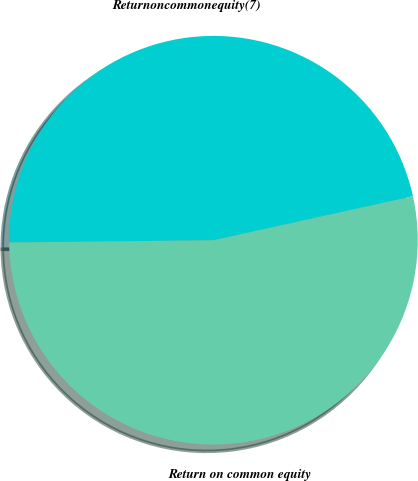Convert chart. <chart><loc_0><loc_0><loc_500><loc_500><pie_chart><fcel>Returnoncommonequity(7)<fcel>Return on common equity<nl><fcel>46.72%<fcel>53.28%<nl></chart> 